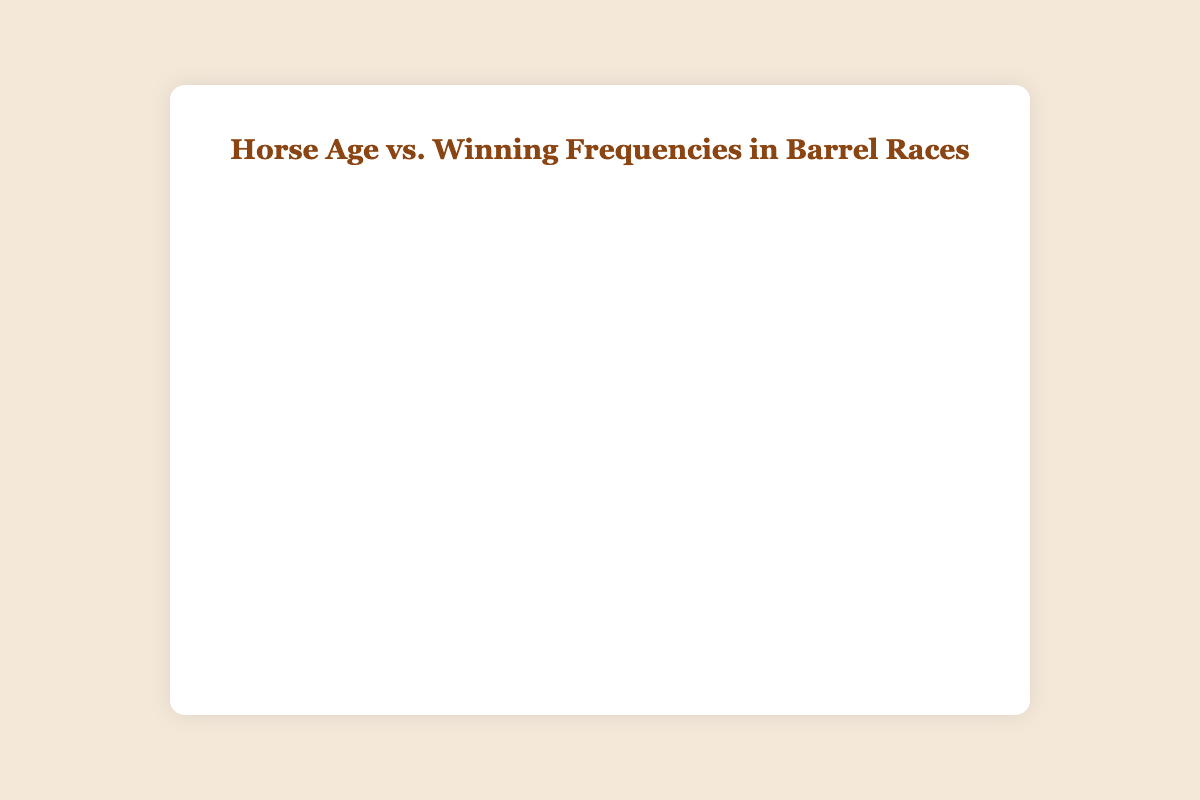How many data points are displayed in the scatter plot? There are nine data points in the data array provided. Each point corresponds to a pair of (horse_age, winning_frequency) values.
Answer: 9 What does the trend line indicate about the relationship between horse age and winning frequency? The trend line indicates the overall trend in the data. If it slopes upwards, it suggests that as the horse's age increases, the winning frequency tends to increase as well. Conversely, if it slopes downwards, it indicates a decrease in winning frequency with increasing age.
Answer: It shows the relationship, increasing or decreasing What is the winning frequency when the horse age is 9? By looking at the scatter plot, locate the data point corresponding to a horse age of 9 on the x-axis. The winning frequency at this point is found by checking the y-axis value.
Answer: 9 Which horse age has the lowest winning frequency? By checking each data point on the scatter plot, identify the one that is lowest on the y-axis. This corresponds to the lowest winning frequency.
Answer: 4 (age) with frequency 3 How many horse ages have winning frequencies greater than 5? Count the number of points on the scatter plot that are above the y-axis value of 5.
Answer: 5 What is the range of winning frequencies present in the data? The range is calculated by finding the difference between the highest and lowest winning frequencies in the scatter plot.
Answer: 6 (from 3 to 9) How does the winning frequency at horse age 10 compare to that at horse age 12? Locate the points corresponding to horse ages 10 and 12 on the scatter plot and compare their y-axis values.
Answer: Age 10 has 6, and age 12 has 5; hence, age 10 has a higher winning frequency What age seems to be the peak of winning frequency, based on the trend line? The peak of the trend line is identified where it reaches the highest y-value. Find the approximate age corresponding to this peak on the x-axis.
Answer: Around age 9 If you were to categorize the age ranges into "young" (4-7), "prime" (8-10), and "senior" (11-12), which category has the highest average winning frequency? Calculate the average winning frequency for each category group, then compare these averages.
Answer: Prime (average of 7.67) 